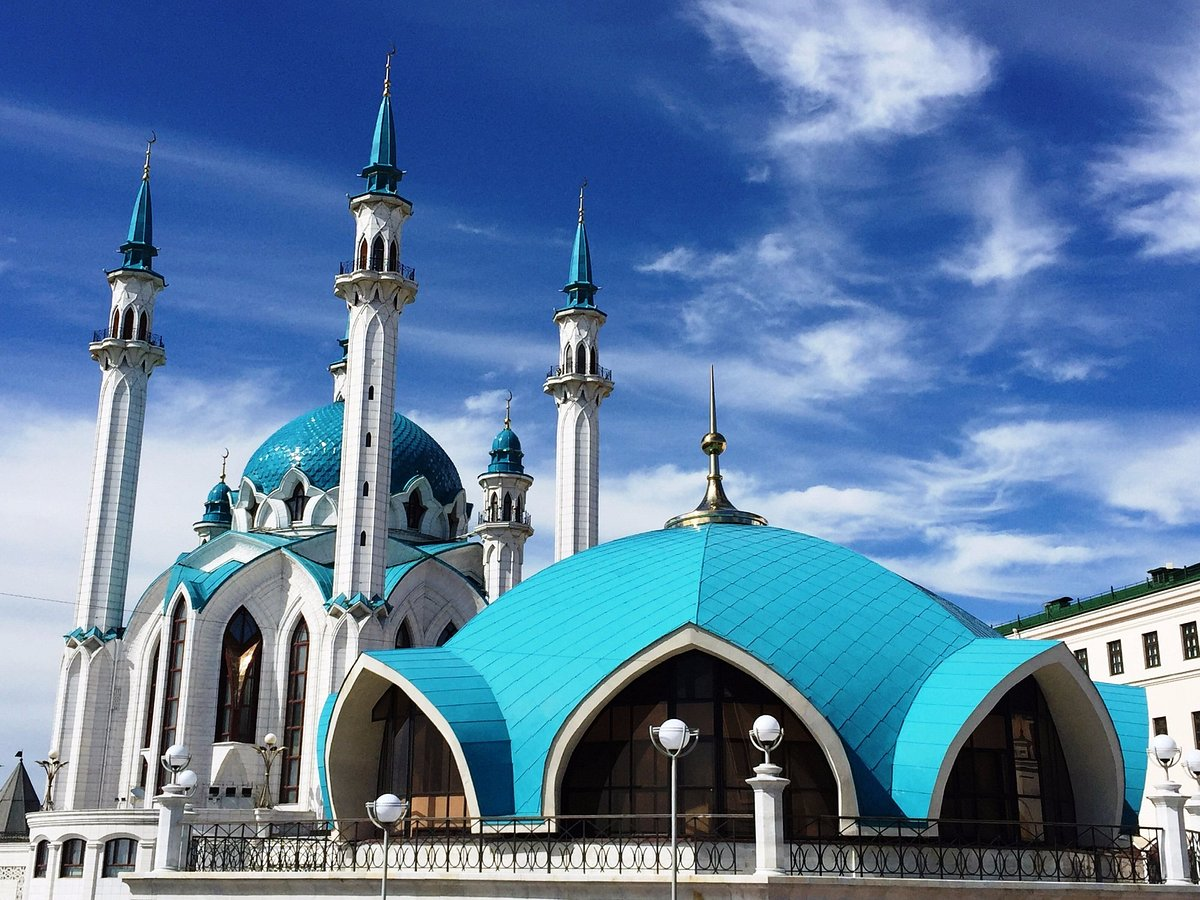Can you tell me more about the historical relevance of this mosque in Kazan’s history? Certainly! The Qolşärif Mosque, prominently situated within the Kazan Kremlin, holds great historical and cultural significance. Originally built in the 16th century, it was one of the largest mosques in Russia, and served as a major educational and religious hub until its destruction in 1552 during Ivan the Terrible's conquest of Kazan. The reconstruction, which was completed in 2005, marks a revival of Tatar heritage and serves as a monument to the resilience of the Tatar people and their culture. 